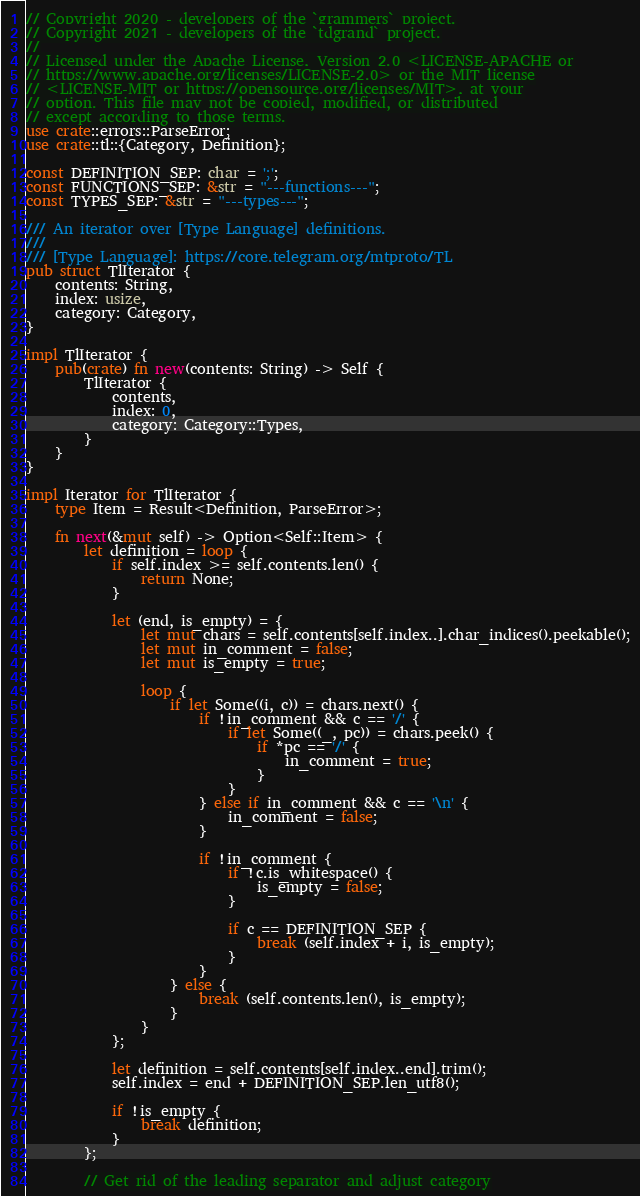<code> <loc_0><loc_0><loc_500><loc_500><_Rust_>// Copyright 2020 - developers of the `grammers` project.
// Copyright 2021 - developers of the `tdgrand` project.
//
// Licensed under the Apache License, Version 2.0 <LICENSE-APACHE or
// https://www.apache.org/licenses/LICENSE-2.0> or the MIT license
// <LICENSE-MIT or https://opensource.org/licenses/MIT>, at your
// option. This file may not be copied, modified, or distributed
// except according to those terms.
use crate::errors::ParseError;
use crate::tl::{Category, Definition};

const DEFINITION_SEP: char = ';';
const FUNCTIONS_SEP: &str = "---functions---";
const TYPES_SEP: &str = "---types---";

/// An iterator over [Type Language] definitions.
///
/// [Type Language]: https://core.telegram.org/mtproto/TL
pub struct TlIterator {
    contents: String,
    index: usize,
    category: Category,
}

impl TlIterator {
    pub(crate) fn new(contents: String) -> Self {
        TlIterator {
            contents,
            index: 0,
            category: Category::Types,
        }
    }
}

impl Iterator for TlIterator {
    type Item = Result<Definition, ParseError>;

    fn next(&mut self) -> Option<Self::Item> {
        let definition = loop {
            if self.index >= self.contents.len() {
                return None;
            }

            let (end, is_empty) = {
                let mut chars = self.contents[self.index..].char_indices().peekable();
                let mut in_comment = false;
                let mut is_empty = true;

                loop {
                    if let Some((i, c)) = chars.next() {
                        if !in_comment && c == '/' {
                            if let Some((_, pc)) = chars.peek() {
                                if *pc == '/' {
                                    in_comment = true;
                                }
                            }
                        } else if in_comment && c == '\n' {
                            in_comment = false;
                        }

                        if !in_comment {
                            if !c.is_whitespace() {
                                is_empty = false;
                            }

                            if c == DEFINITION_SEP {
                                break (self.index + i, is_empty);
                            }
                        }
                    } else {
                        break (self.contents.len(), is_empty);
                    }
                }
            };

            let definition = self.contents[self.index..end].trim();
            self.index = end + DEFINITION_SEP.len_utf8();

            if !is_empty {
                break definition;
            }
        };

        // Get rid of the leading separator and adjust category</code> 